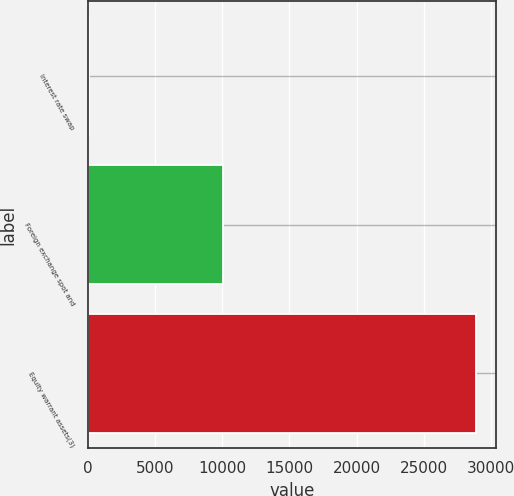<chart> <loc_0><loc_0><loc_500><loc_500><bar_chart><fcel>Interest rate swap<fcel>Foreign exchange spot and<fcel>Equity warrant assets(3)<nl><fcel>49<fcel>10011<fcel>28928<nl></chart> 